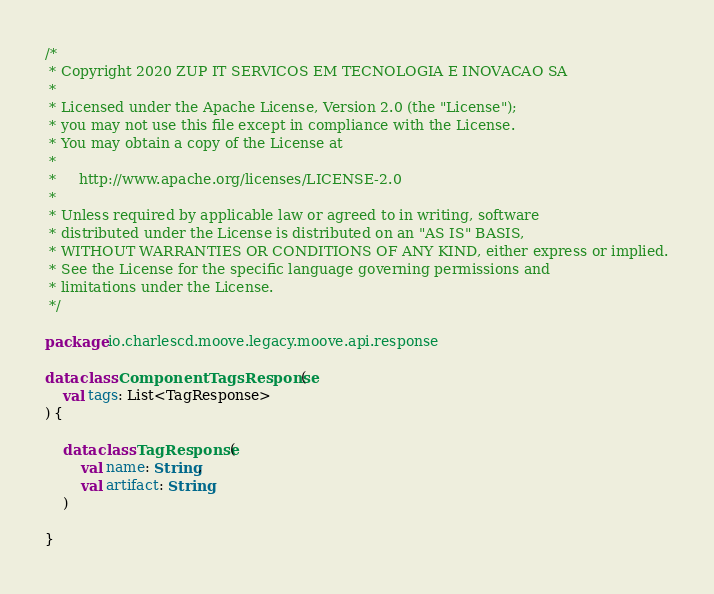Convert code to text. <code><loc_0><loc_0><loc_500><loc_500><_Kotlin_>/*
 * Copyright 2020 ZUP IT SERVICOS EM TECNOLOGIA E INOVACAO SA
 *
 * Licensed under the Apache License, Version 2.0 (the "License");
 * you may not use this file except in compliance with the License.
 * You may obtain a copy of the License at
 *
 *     http://www.apache.org/licenses/LICENSE-2.0
 *
 * Unless required by applicable law or agreed to in writing, software
 * distributed under the License is distributed on an "AS IS" BASIS,
 * WITHOUT WARRANTIES OR CONDITIONS OF ANY KIND, either express or implied.
 * See the License for the specific language governing permissions and
 * limitations under the License.
 */

package io.charlescd.moove.legacy.moove.api.response

data class ComponentTagsResponse(
    val tags: List<TagResponse>
) {

    data class TagResponse(
        val name: String,
        val artifact: String
    )

}
</code> 